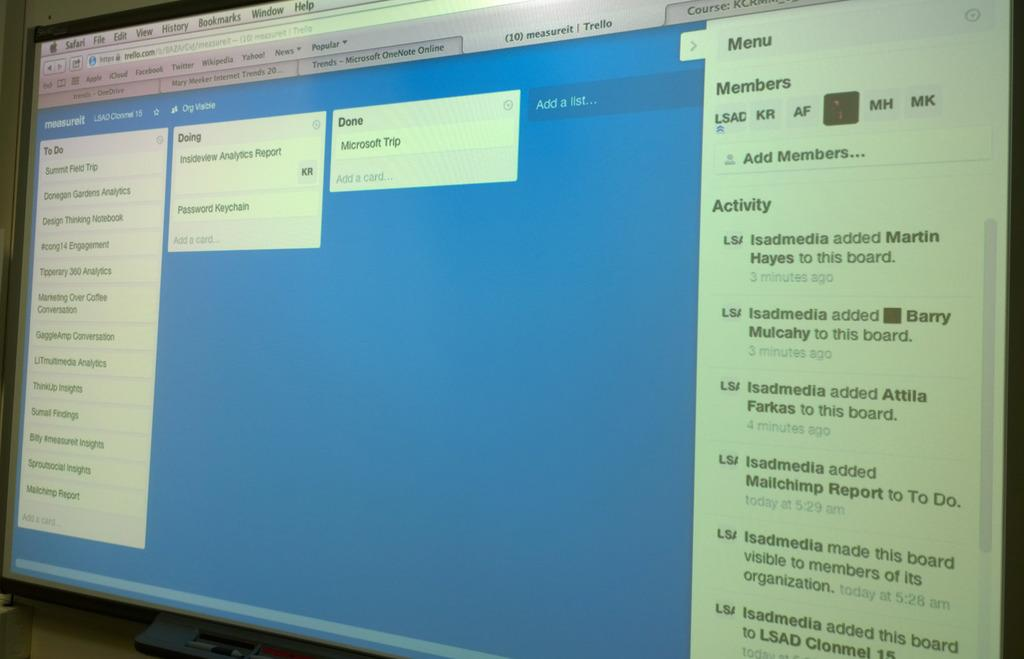Provide a one-sentence caption for the provided image. A computer screen shows a to do list, a doing list, and a done list. 